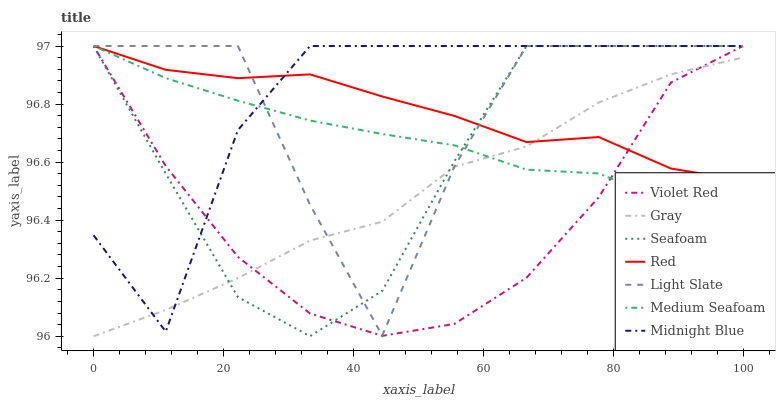Does Midnight Blue have the minimum area under the curve?
Answer yes or no. No. Does Violet Red have the maximum area under the curve?
Answer yes or no. No. Is Violet Red the smoothest?
Answer yes or no. No. Is Violet Red the roughest?
Answer yes or no. No. Does Violet Red have the lowest value?
Answer yes or no. No. 